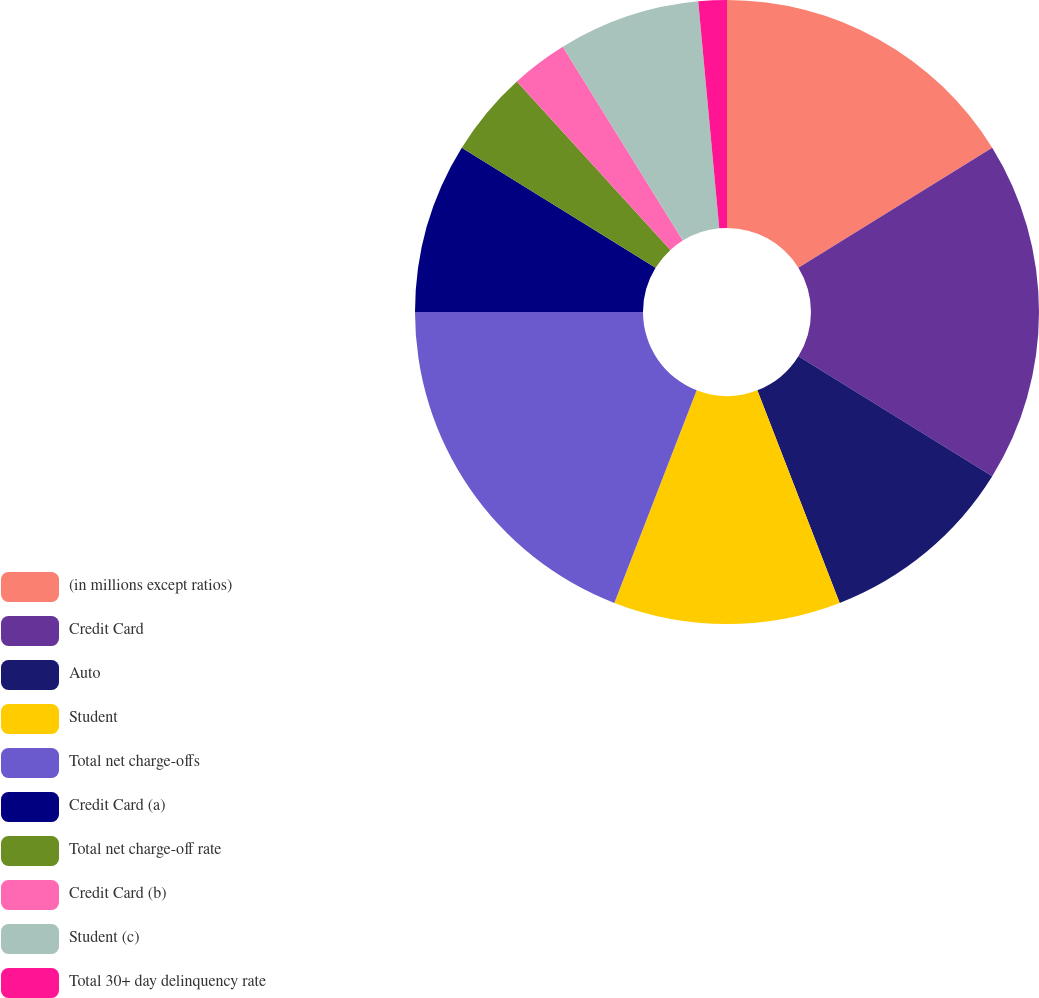Convert chart to OTSL. <chart><loc_0><loc_0><loc_500><loc_500><pie_chart><fcel>(in millions except ratios)<fcel>Credit Card<fcel>Auto<fcel>Student<fcel>Total net charge-offs<fcel>Credit Card (a)<fcel>Total net charge-off rate<fcel>Credit Card (b)<fcel>Student (c)<fcel>Total 30+ day delinquency rate<nl><fcel>16.17%<fcel>17.65%<fcel>10.29%<fcel>11.76%<fcel>19.12%<fcel>8.82%<fcel>4.41%<fcel>2.94%<fcel>7.35%<fcel>1.47%<nl></chart> 